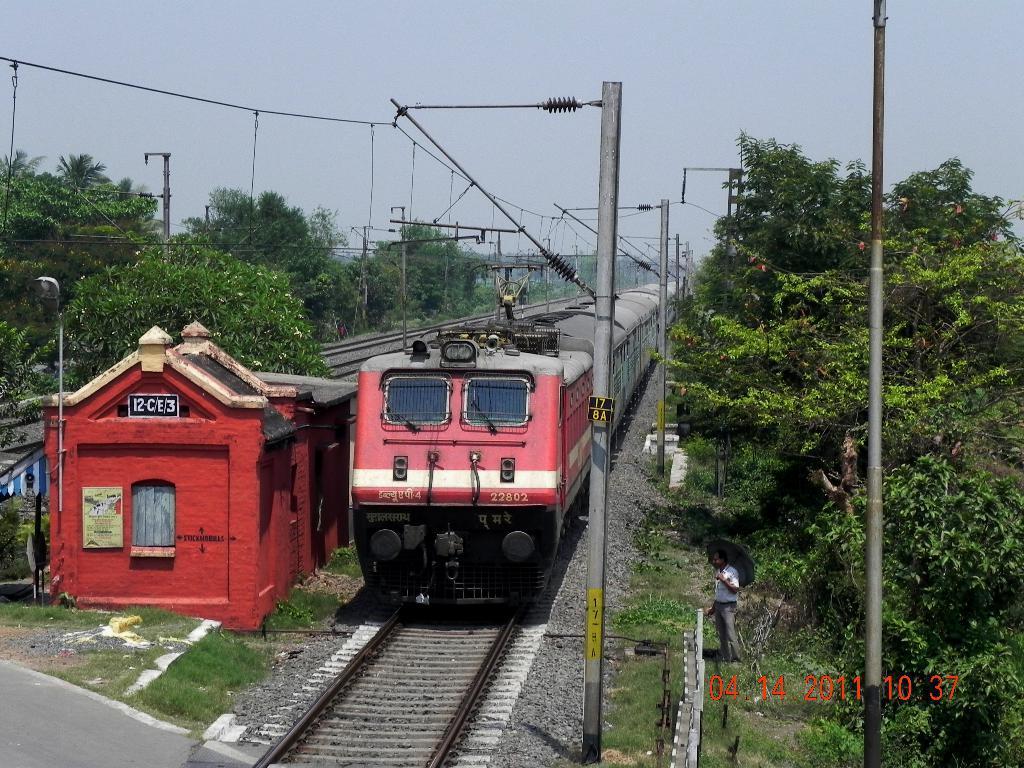In one or two sentences, can you explain what this image depicts? In this image, we can see a train is on the track. Here a person is holding an umbrella and standing on the grass. At the bottom of the image, we can see a watermark, few grasses, road. In the middle of the image, we can see so many trees, shed, window, board, poles, ropes, wires. Top of the image, there is a sky. 